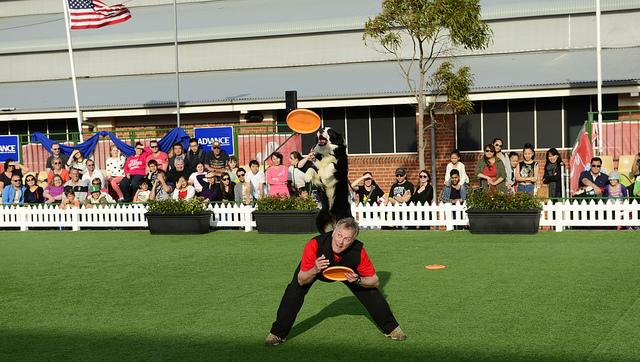Is there a flag here?
Concise answer only. Yes. How many frisbees are there?
Keep it brief. 3. Is this real grass on the ground?
Write a very short answer. No. 